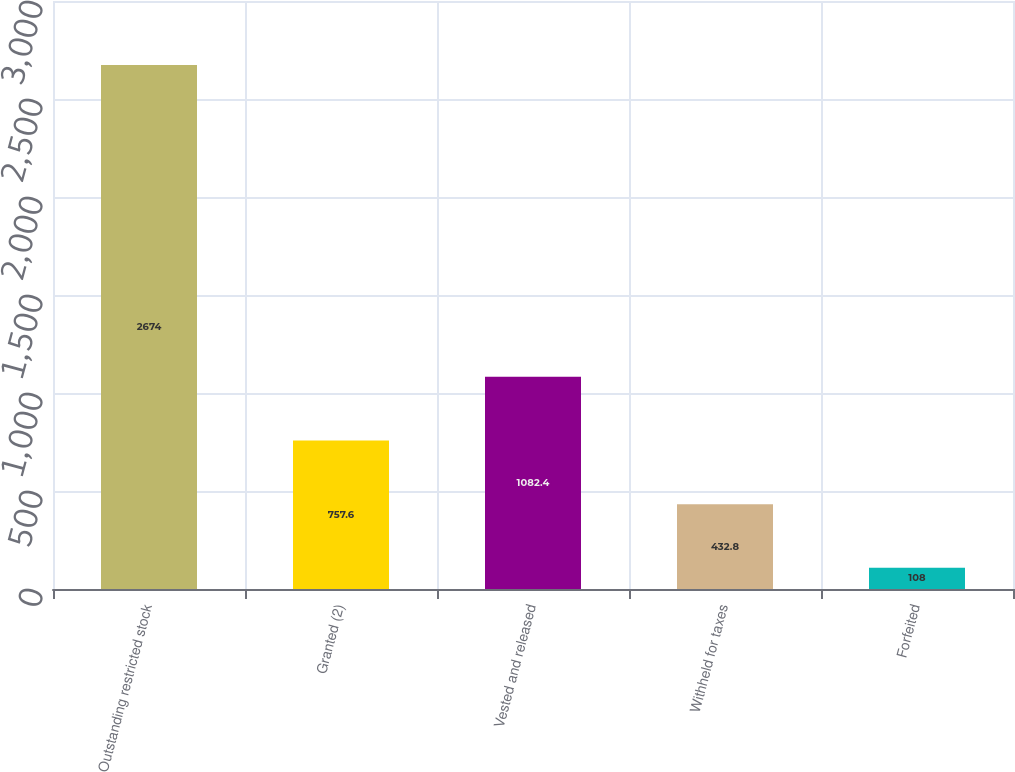Convert chart to OTSL. <chart><loc_0><loc_0><loc_500><loc_500><bar_chart><fcel>Outstanding restricted stock<fcel>Granted (2)<fcel>Vested and released<fcel>Withheld for taxes<fcel>Forfeited<nl><fcel>2674<fcel>757.6<fcel>1082.4<fcel>432.8<fcel>108<nl></chart> 